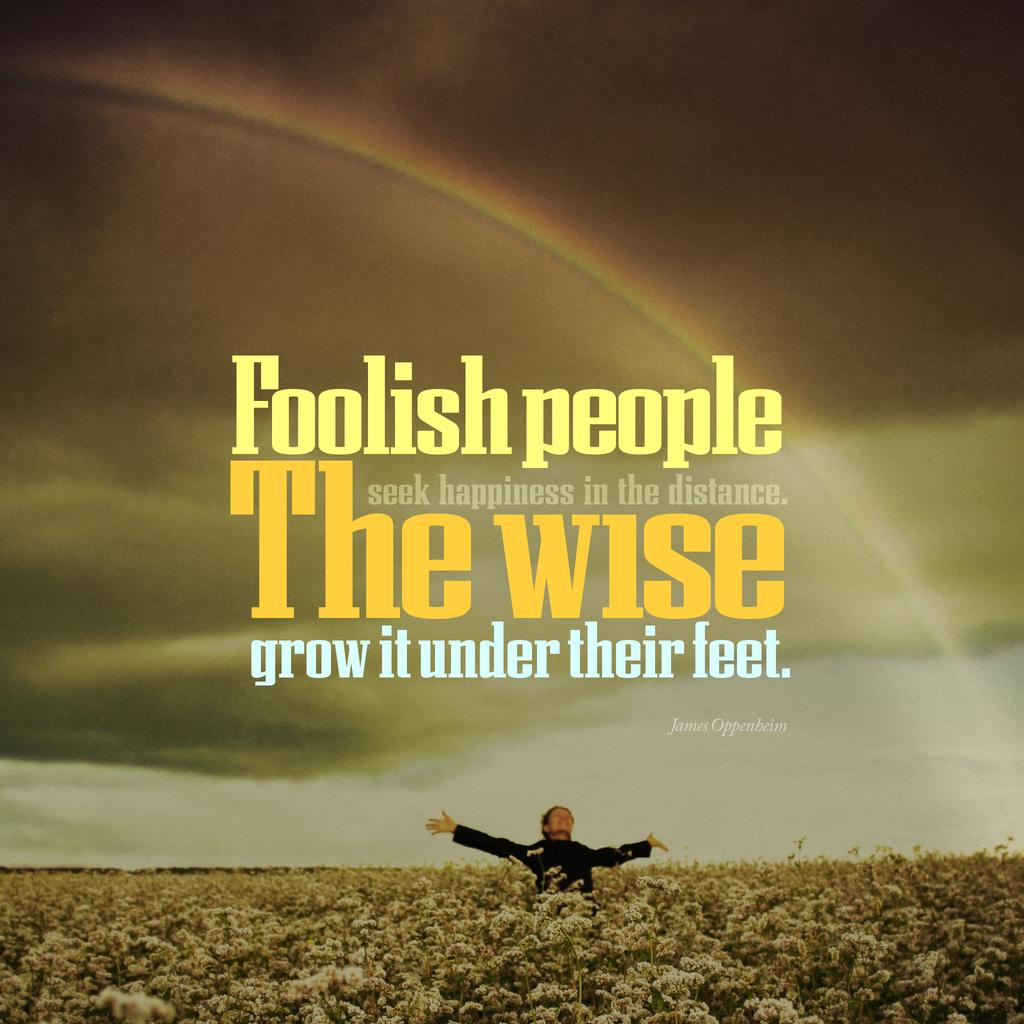Are you saying only farmers are wise?
Offer a terse response. Yes. Who grows it under their feet?
Offer a very short reply. The wise. 